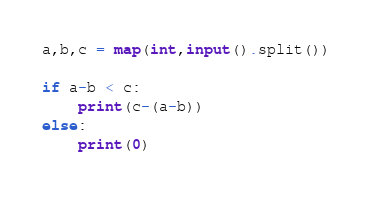<code> <loc_0><loc_0><loc_500><loc_500><_Python_>a,b,c = map(int,input().split())

if a-b < c:
    print(c-(a-b))
else:
    print(0)</code> 